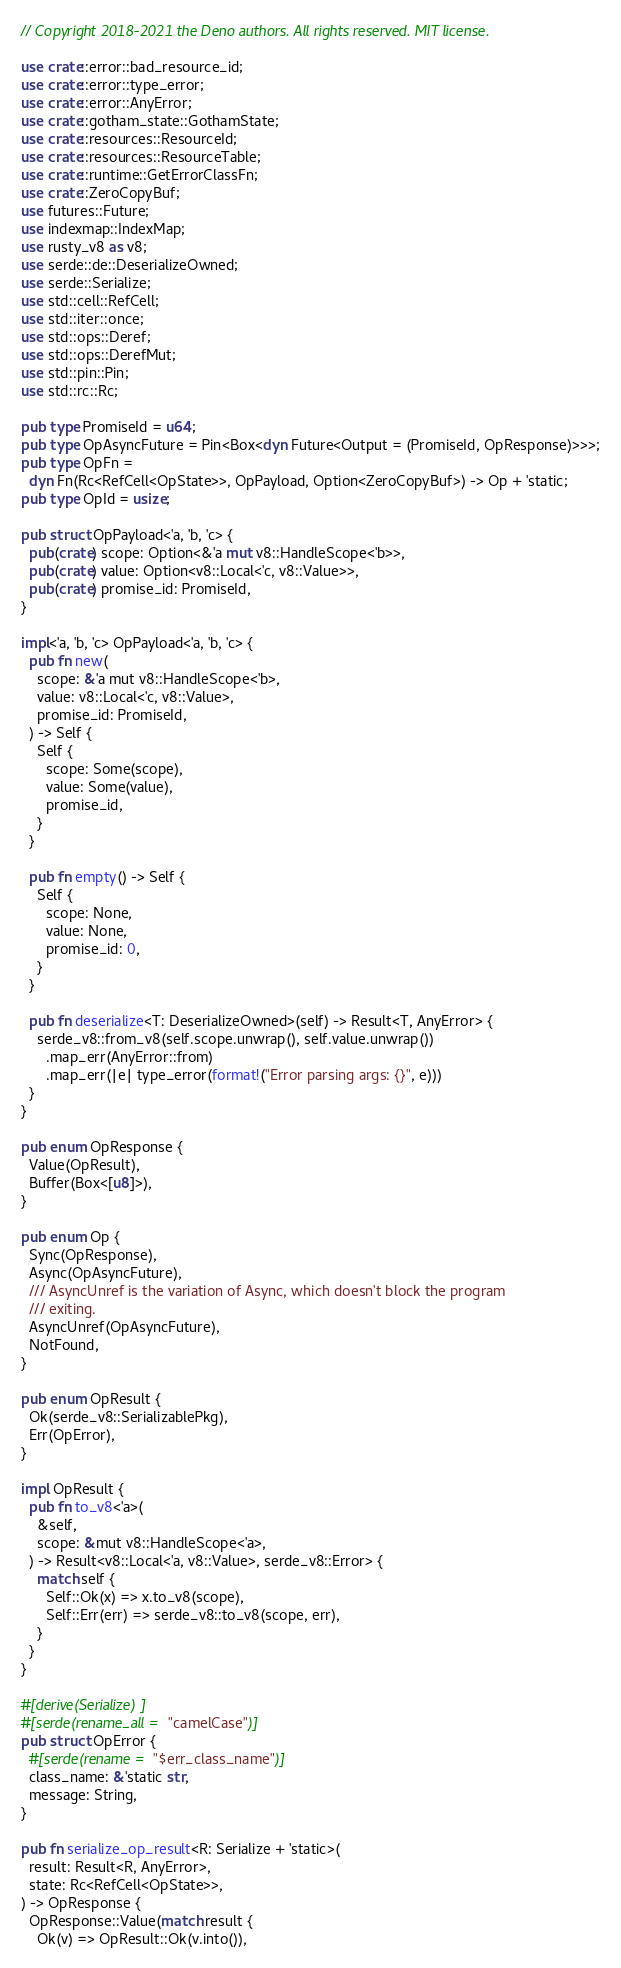Convert code to text. <code><loc_0><loc_0><loc_500><loc_500><_Rust_>// Copyright 2018-2021 the Deno authors. All rights reserved. MIT license.

use crate::error::bad_resource_id;
use crate::error::type_error;
use crate::error::AnyError;
use crate::gotham_state::GothamState;
use crate::resources::ResourceId;
use crate::resources::ResourceTable;
use crate::runtime::GetErrorClassFn;
use crate::ZeroCopyBuf;
use futures::Future;
use indexmap::IndexMap;
use rusty_v8 as v8;
use serde::de::DeserializeOwned;
use serde::Serialize;
use std::cell::RefCell;
use std::iter::once;
use std::ops::Deref;
use std::ops::DerefMut;
use std::pin::Pin;
use std::rc::Rc;

pub type PromiseId = u64;
pub type OpAsyncFuture = Pin<Box<dyn Future<Output = (PromiseId, OpResponse)>>>;
pub type OpFn =
  dyn Fn(Rc<RefCell<OpState>>, OpPayload, Option<ZeroCopyBuf>) -> Op + 'static;
pub type OpId = usize;

pub struct OpPayload<'a, 'b, 'c> {
  pub(crate) scope: Option<&'a mut v8::HandleScope<'b>>,
  pub(crate) value: Option<v8::Local<'c, v8::Value>>,
  pub(crate) promise_id: PromiseId,
}

impl<'a, 'b, 'c> OpPayload<'a, 'b, 'c> {
  pub fn new(
    scope: &'a mut v8::HandleScope<'b>,
    value: v8::Local<'c, v8::Value>,
    promise_id: PromiseId,
  ) -> Self {
    Self {
      scope: Some(scope),
      value: Some(value),
      promise_id,
    }
  }

  pub fn empty() -> Self {
    Self {
      scope: None,
      value: None,
      promise_id: 0,
    }
  }

  pub fn deserialize<T: DeserializeOwned>(self) -> Result<T, AnyError> {
    serde_v8::from_v8(self.scope.unwrap(), self.value.unwrap())
      .map_err(AnyError::from)
      .map_err(|e| type_error(format!("Error parsing args: {}", e)))
  }
}

pub enum OpResponse {
  Value(OpResult),
  Buffer(Box<[u8]>),
}

pub enum Op {
  Sync(OpResponse),
  Async(OpAsyncFuture),
  /// AsyncUnref is the variation of Async, which doesn't block the program
  /// exiting.
  AsyncUnref(OpAsyncFuture),
  NotFound,
}

pub enum OpResult {
  Ok(serde_v8::SerializablePkg),
  Err(OpError),
}

impl OpResult {
  pub fn to_v8<'a>(
    &self,
    scope: &mut v8::HandleScope<'a>,
  ) -> Result<v8::Local<'a, v8::Value>, serde_v8::Error> {
    match self {
      Self::Ok(x) => x.to_v8(scope),
      Self::Err(err) => serde_v8::to_v8(scope, err),
    }
  }
}

#[derive(Serialize)]
#[serde(rename_all = "camelCase")]
pub struct OpError {
  #[serde(rename = "$err_class_name")]
  class_name: &'static str,
  message: String,
}

pub fn serialize_op_result<R: Serialize + 'static>(
  result: Result<R, AnyError>,
  state: Rc<RefCell<OpState>>,
) -> OpResponse {
  OpResponse::Value(match result {
    Ok(v) => OpResult::Ok(v.into()),</code> 